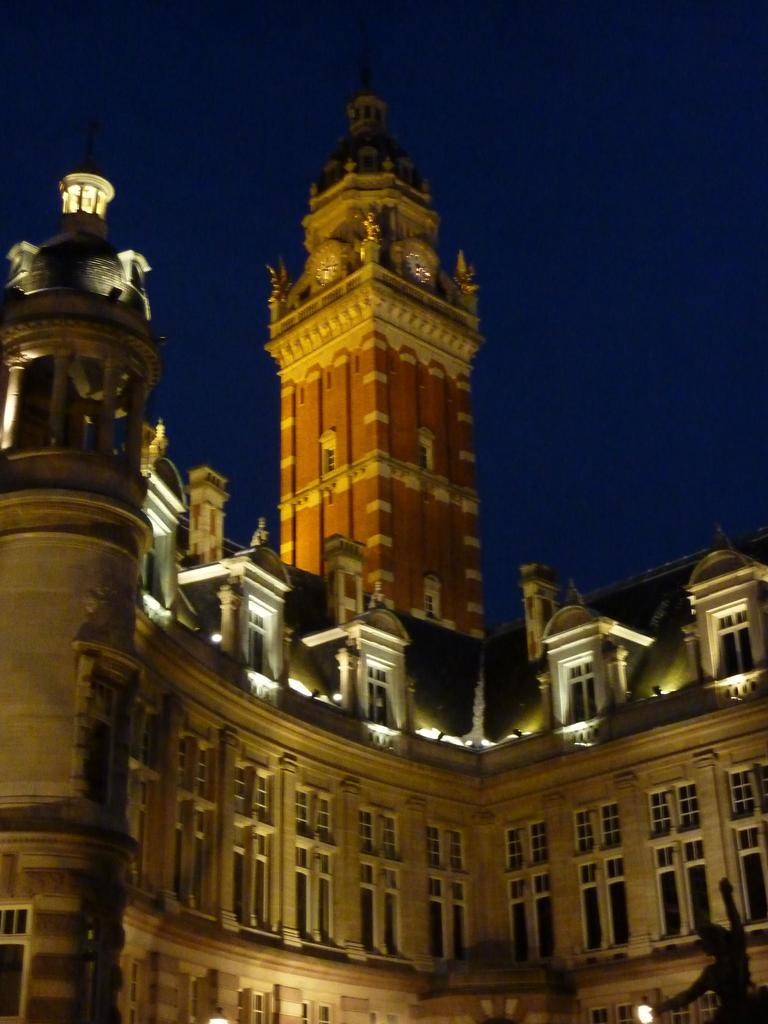What is the main subject in the front of the image? There is a statue in the front of the image. What structure is located in the center of the image? There is a building in the center of the image. What can be seen in the background of the image? There is a tower in the background of the image. Can you see any icicles hanging from the statue in the image? There are no icicles present in the image; the statue is not depicted with any icicles. What type of wine is being served in the building in the image? There is no wine or indication of any beverage being served in the building in the image. 